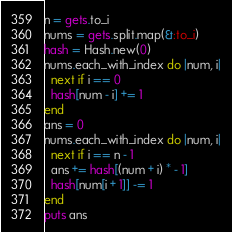Convert code to text. <code><loc_0><loc_0><loc_500><loc_500><_Ruby_>n = gets.to_i
nums = gets.split.map(&:to_i)
hash = Hash.new(0)
nums.each_with_index do |num, i|
  next if i == 0
  hash[num - i] += 1
end
ans = 0
nums.each_with_index do |num, i|
  next if i == n - 1
  ans += hash[(num + i) * - 1]
  hash[num[i + 1]] -= 1
end
puts ans
</code> 